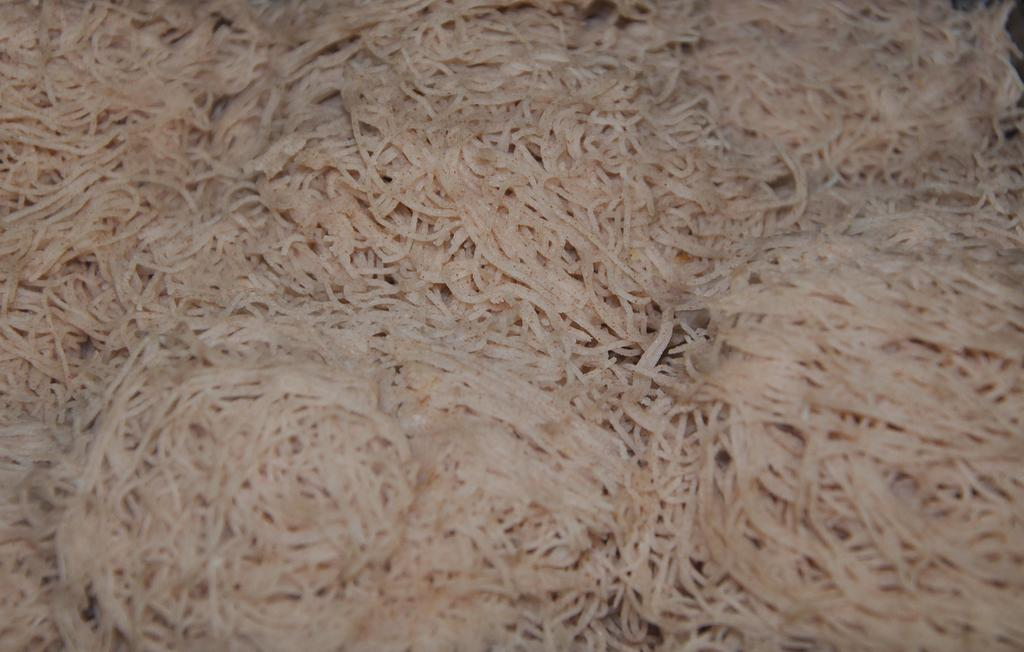What is the main subject in the foreground of the image? There are noodles in the foreground of the image. What type of volcano can be seen erupting in the background of the image? There is no volcano present in the image; it only features noodles in the foreground. What is the artist's thumb doing on the canvas in the image? There is no canvas or artist's thumb present in the image; it only features noodles in the foreground. 